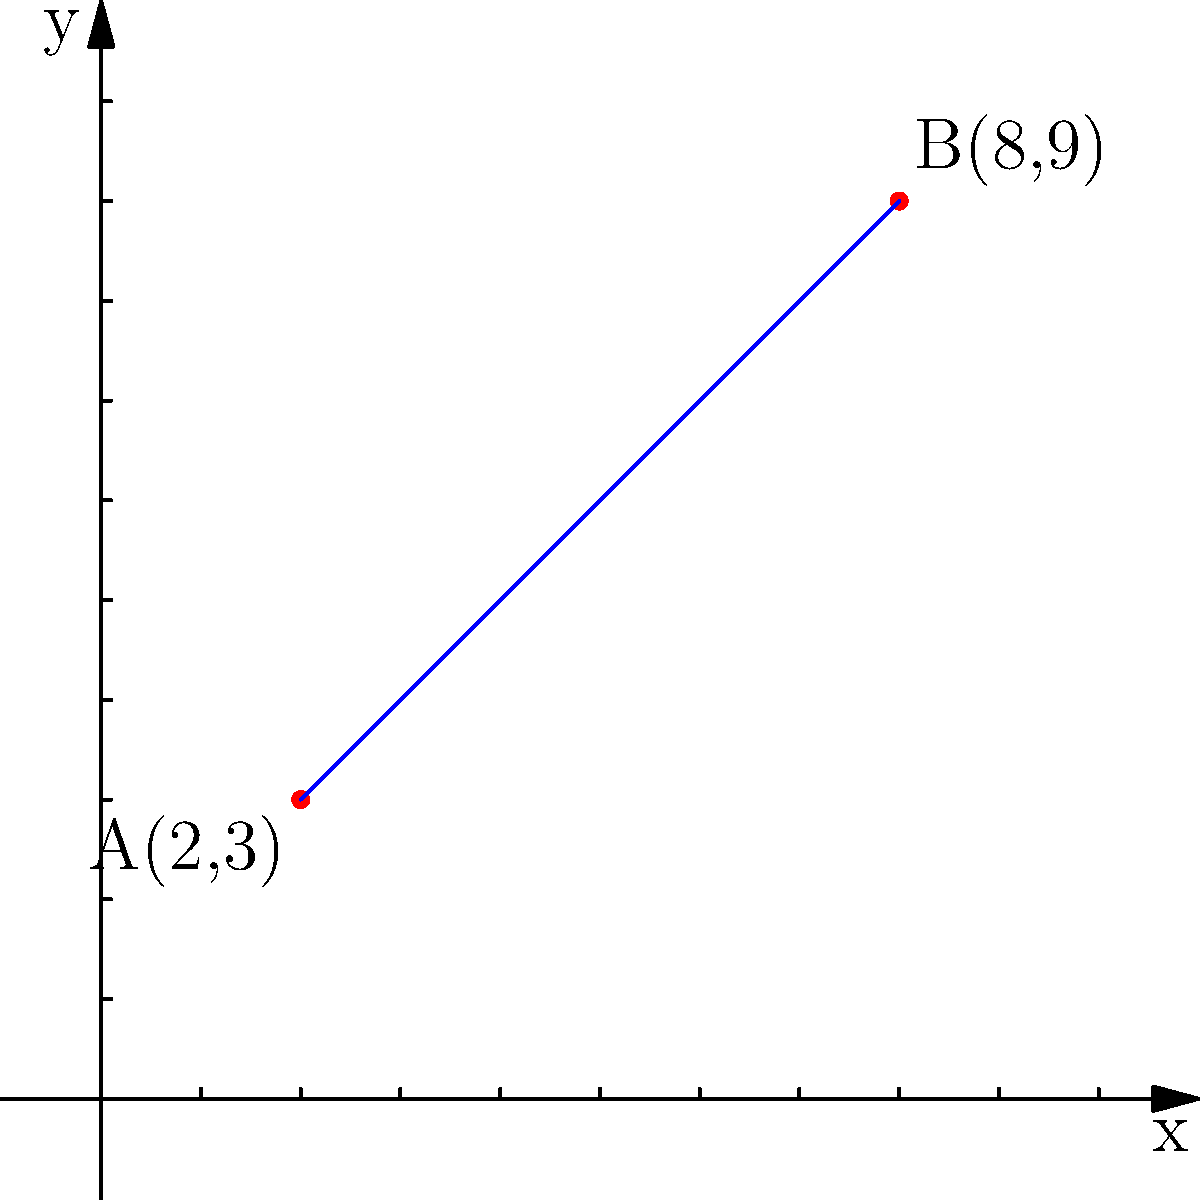During a race analysis, you're studying a simplified model of a race track on a coordinate system. Two critical points on the track are marked: point A(2,3) and point B(8,9). Calculate the straight-line distance between these two points on the track. Round your answer to two decimal places. To find the distance between two points, we can use the distance formula, which is derived from the Pythagorean theorem:

$d = \sqrt{(x_2-x_1)^2 + (y_2-y_1)^2}$

Where $(x_1,y_1)$ are the coordinates of the first point and $(x_2,y_2)$ are the coordinates of the second point.

Let's solve this step-by-step:

1) Identify the coordinates:
   Point A: $(x_1,y_1) = (2,3)$
   Point B: $(x_2,y_2) = (8,9)$

2) Plug these into the distance formula:
   $d = \sqrt{(8-2)^2 + (9-3)^2}$

3) Simplify inside the parentheses:
   $d = \sqrt{6^2 + 6^2}$

4) Calculate the squares:
   $d = \sqrt{36 + 36}$

5) Add inside the square root:
   $d = \sqrt{72}$

6) Simplify the square root:
   $d = 6\sqrt{2}$

7) Use a calculator to get the decimal approximation and round to two decimal places:
   $d \approx 8.49$

Therefore, the distance between points A and B is approximately 8.49 units.
Answer: 8.49 units 